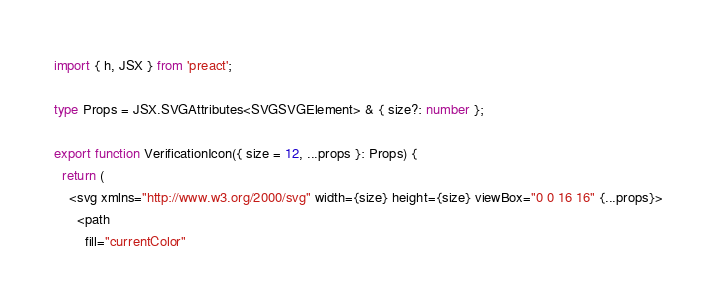<code> <loc_0><loc_0><loc_500><loc_500><_TypeScript_>import { h, JSX } from 'preact';

type Props = JSX.SVGAttributes<SVGSVGElement> & { size?: number };

export function VerificationIcon({ size = 12, ...props }: Props) {
  return (
    <svg xmlns="http://www.w3.org/2000/svg" width={size} height={size} viewBox="0 0 16 16" {...props}>
      <path
        fill="currentColor"</code> 